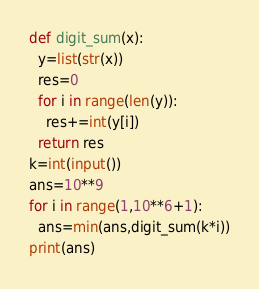Convert code to text. <code><loc_0><loc_0><loc_500><loc_500><_Python_>def digit_sum(x):
  y=list(str(x))
  res=0
  for i in range(len(y)):
    res+=int(y[i])
  return res
k=int(input())
ans=10**9
for i in range(1,10**6+1):
  ans=min(ans,digit_sum(k*i))
print(ans)</code> 